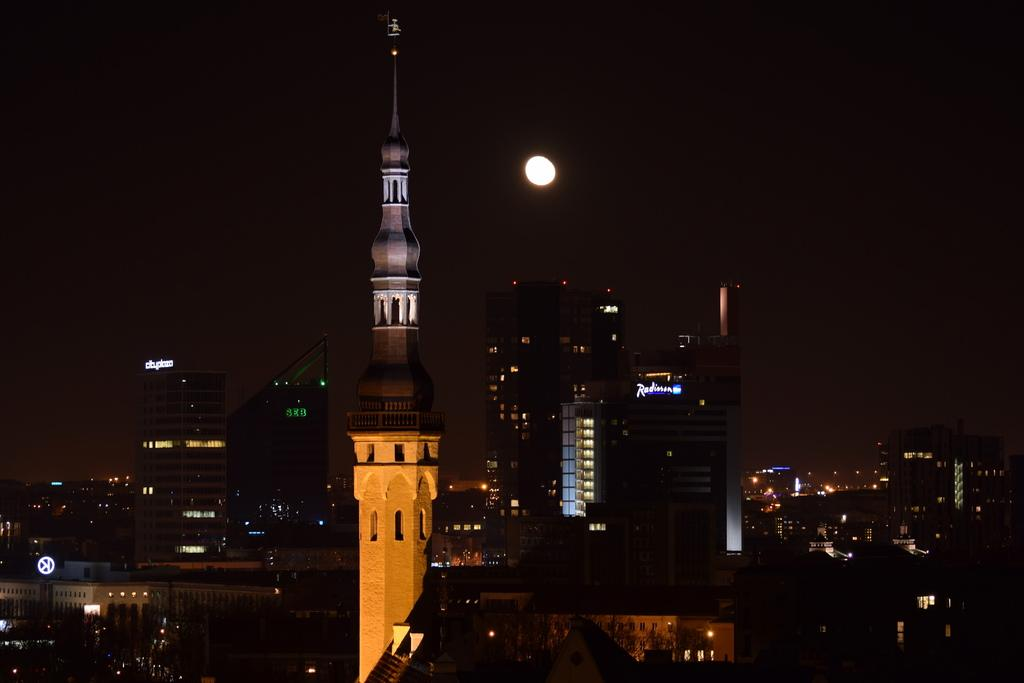What is the main structure in the image? There is a minar in the image. What other structures can be seen in the image? There are buildings in the image. What can be seen illuminating the structures in the image? There are lights in the image. What celestial body is visible in the background of the image? The moon is visible in the background of the image. What else can be seen in the background of the image? The sky is visible in the background of the image. What is your grandmother doing in the image? There is no grandmother present in the image. How quiet is the scene in the image? The image does not convey any information about the noise level or quietness of the scene. 